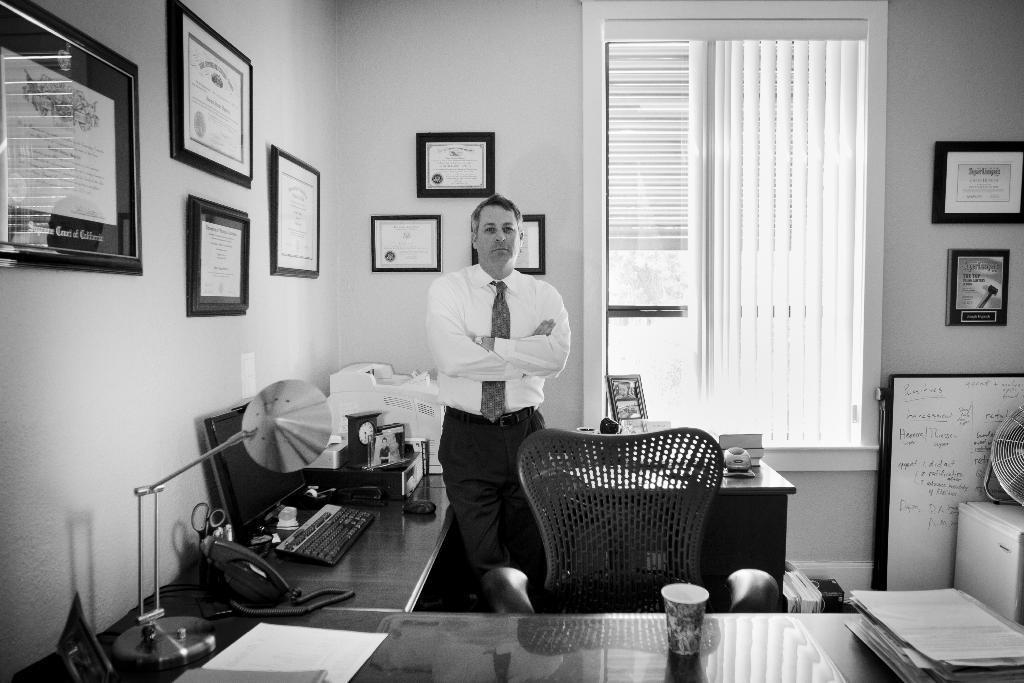In one or two sentences, can you explain what this image depicts? In this image we can see a man wearing white shirt standing and giving a pose into the camera. On the front table we can see table light, laptop and a small clock. In the background there is a white wall with many photo frames. Beside we can see glass window and blinds. 